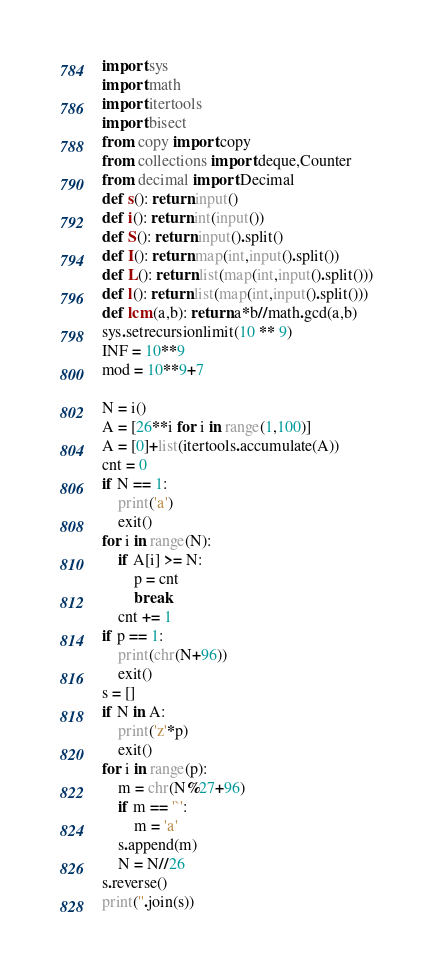<code> <loc_0><loc_0><loc_500><loc_500><_Python_>import sys
import math
import itertools
import bisect
from copy import copy
from collections import deque,Counter
from decimal import Decimal
def s(): return input()
def i(): return int(input())
def S(): return input().split()
def I(): return map(int,input().split())
def L(): return list(map(int,input().split()))
def l(): return list(map(int,input().split()))
def lcm(a,b): return a*b//math.gcd(a,b)
sys.setrecursionlimit(10 ** 9)
INF = 10**9
mod = 10**9+7

N = i()
A = [26**i for i in range(1,100)]
A = [0]+list(itertools.accumulate(A))
cnt = 0
if N == 1:
    print('a')
    exit()
for i in range(N):
    if A[i] >= N:
        p = cnt
        break
    cnt += 1
if p == 1:
    print(chr(N+96))
    exit()
s = []
if N in A:
    print('z'*p)
    exit()
for i in range(p):
    m = chr(N%27+96)
    if m == '`':
        m = 'a'
    s.append(m)
    N = N//26
s.reverse()
print(''.join(s))</code> 